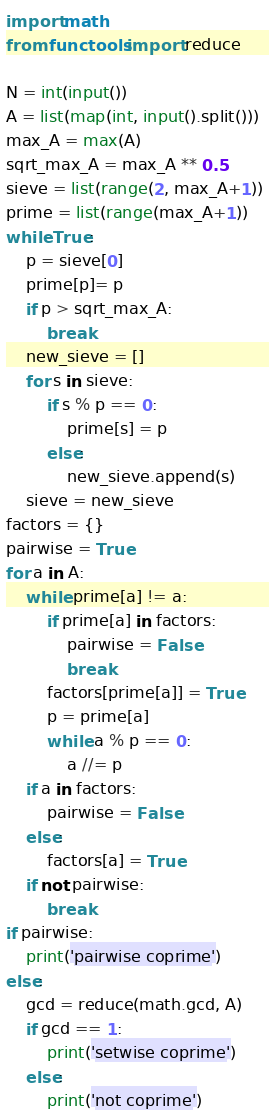Convert code to text. <code><loc_0><loc_0><loc_500><loc_500><_Python_>import math
from functools import reduce

N = int(input())
A = list(map(int, input().split()))
max_A = max(A)
sqrt_max_A = max_A ** 0.5
sieve = list(range(2, max_A+1))
prime = list(range(max_A+1))
while True:
    p = sieve[0]
    prime[p]= p
    if p > sqrt_max_A:
        break
    new_sieve = []
    for s in sieve:
        if s % p == 0:
            prime[s] = p
        else:
            new_sieve.append(s)
    sieve = new_sieve
factors = {}
pairwise = True
for a in A:
    while prime[a] != a:
        if prime[a] in factors:
            pairwise = False
            break
        factors[prime[a]] = True
        p = prime[a]
        while a % p == 0:
            a //= p
    if a in factors:
        pairwise = False
    else:
        factors[a] = True
    if not pairwise:
        break
if pairwise:
    print('pairwise coprime')
else:
    gcd = reduce(math.gcd, A)
    if gcd == 1:
        print('setwise coprime')
    else:
        print('not coprime')
</code> 